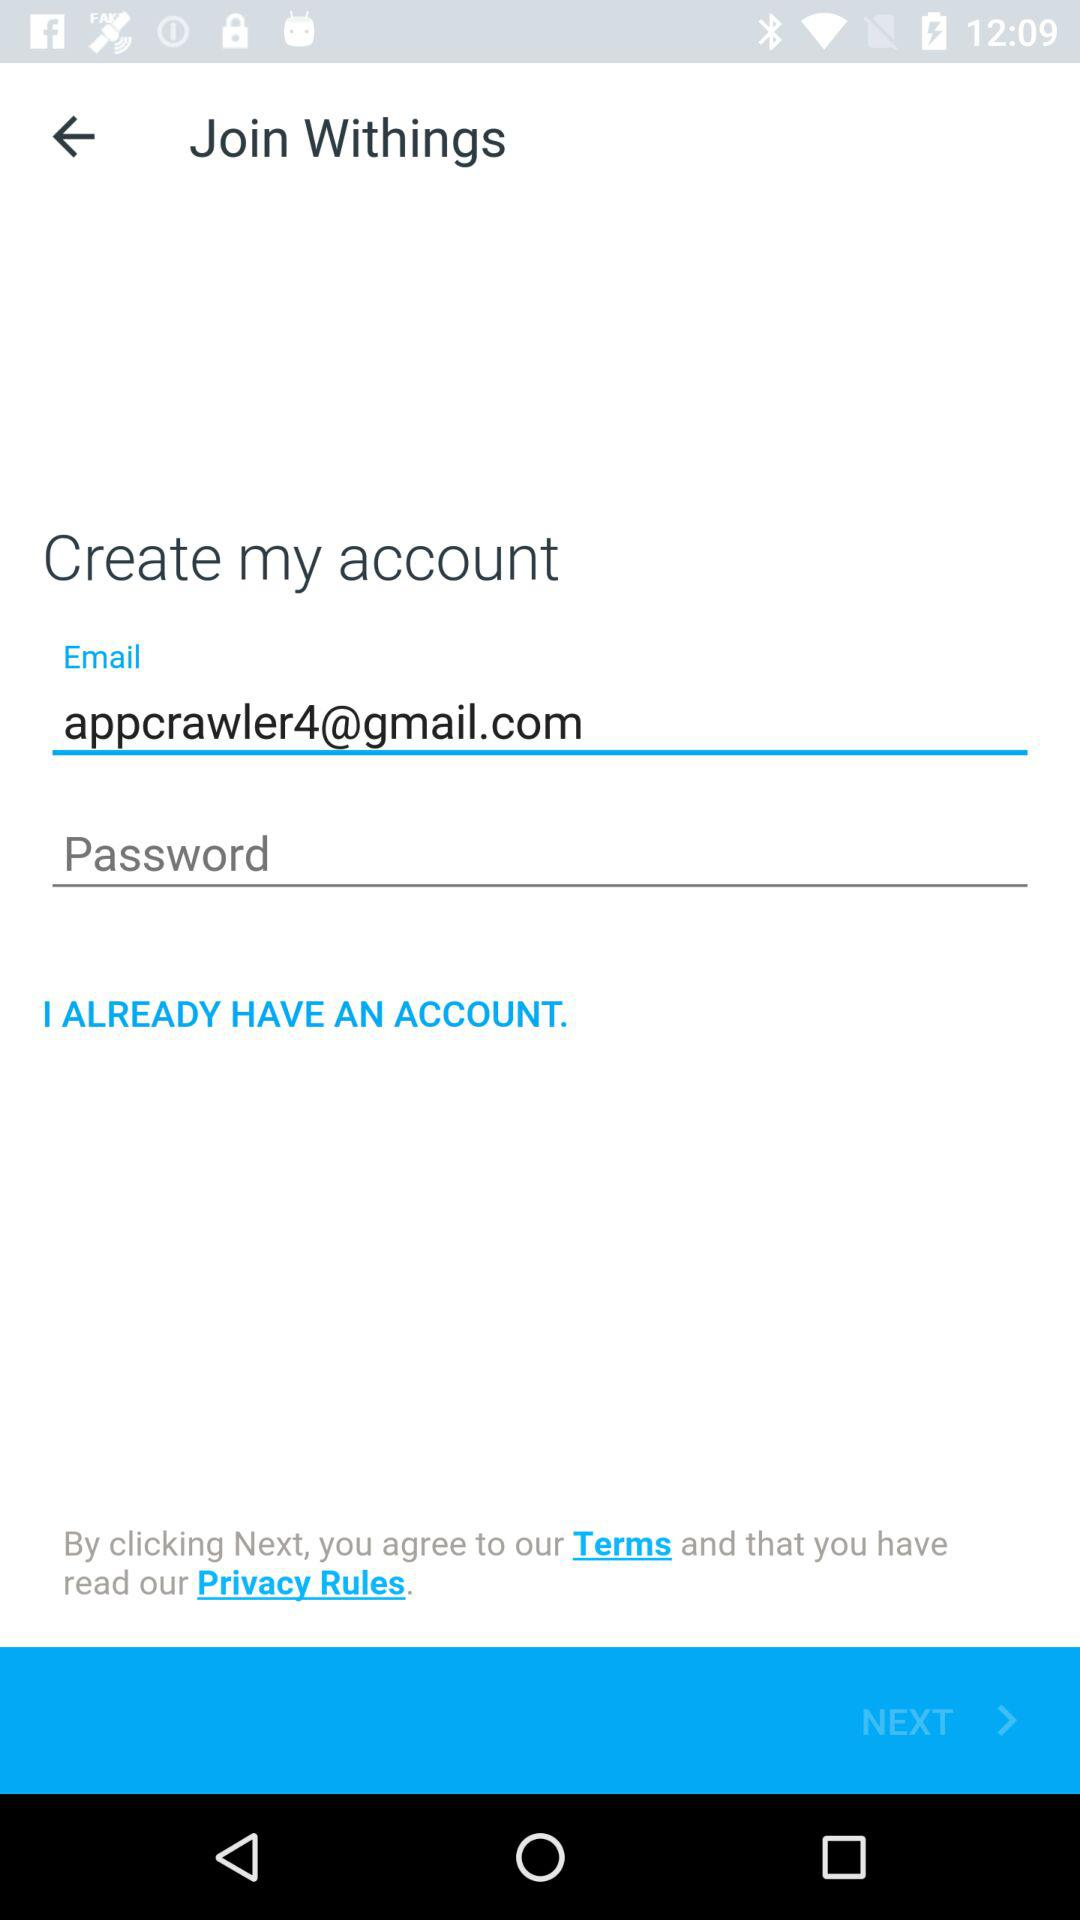What is the name of the application?
When the provided information is insufficient, respond with <no answer>. <no answer> 